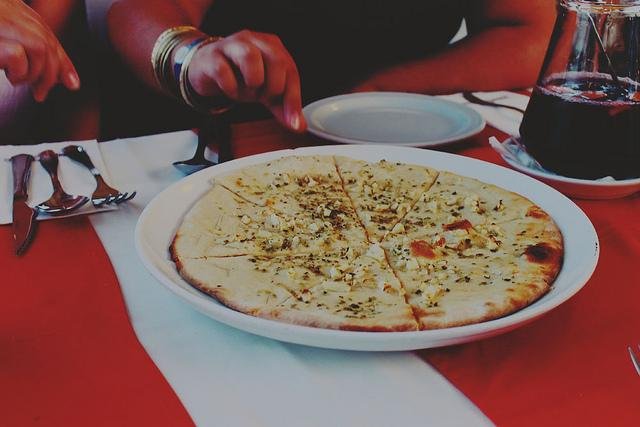What can one of the shiny silver things do? Please explain your reasoning. cut. The utensils can cut and eat. 